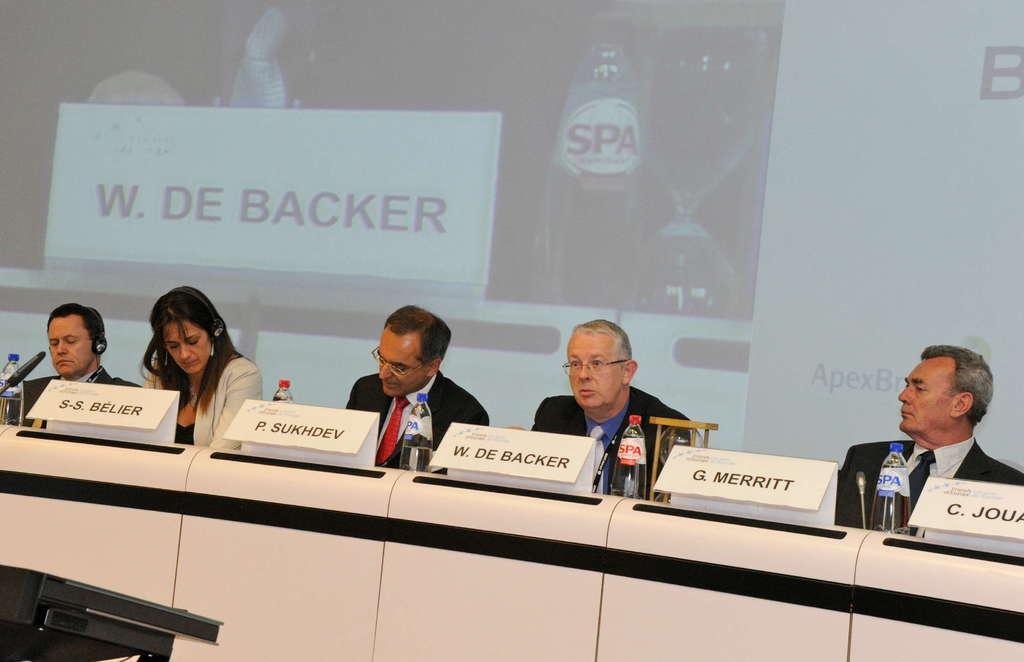Could you give a brief overview of what you see in this image? In this picture we can see five people, bottles, mics, name boards, some objects and in the background we can see the screen. 